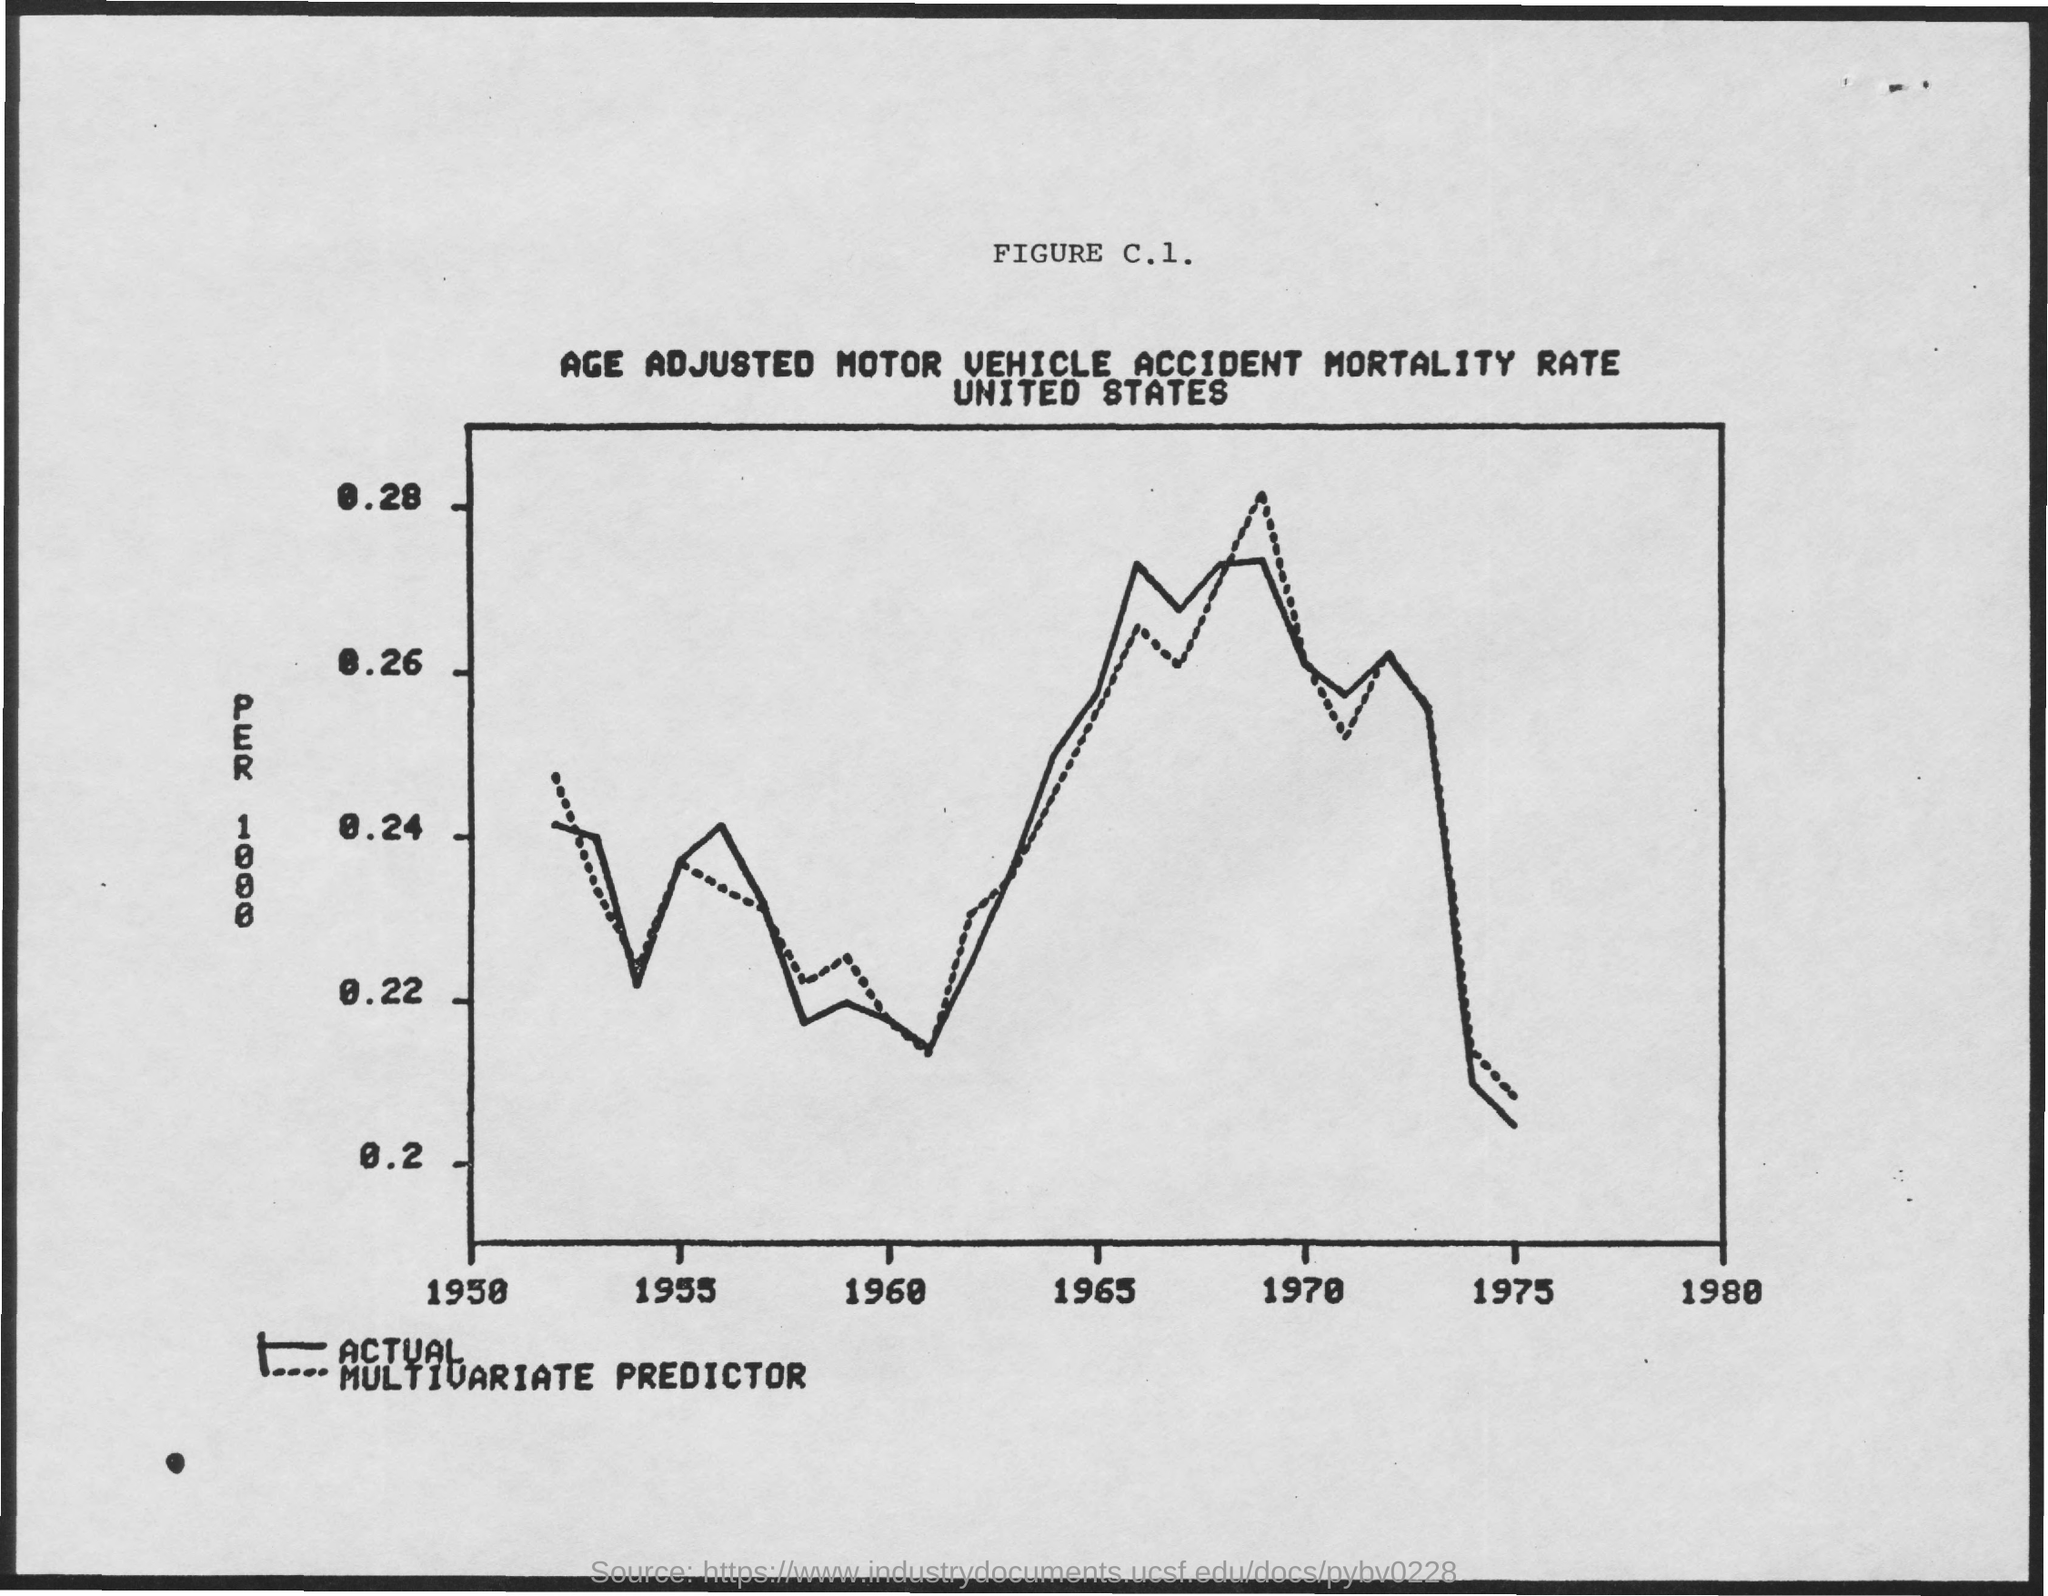Identify some key points in this picture. The title of FIGURE C.1 is the "Age-Adjusted Motor Vehicle Accident Mortality Rate in the United States. The maximum limit shown on the y-axis of Figure c.1 is 0.28. 